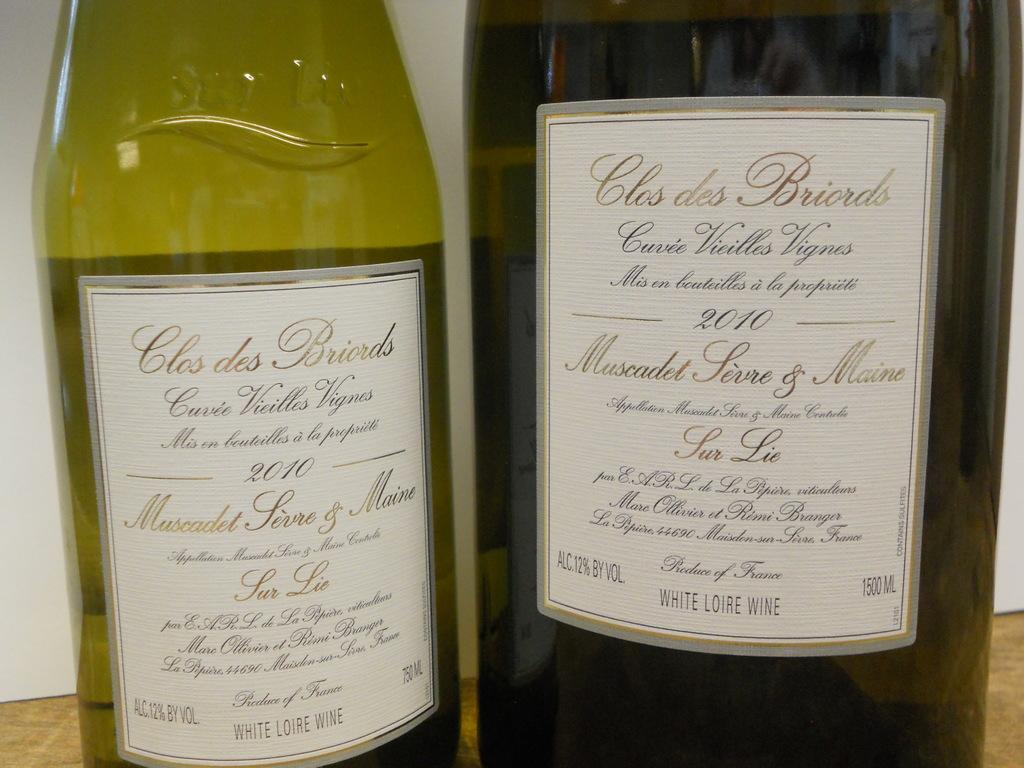What objects are present on the table in the image? There are two wine bottles on the table in the image. Can you describe the table setting or any other objects on the table? The provided facts do not mention any other objects on the table, so we cannot describe a table setting or any other objects. How many goldfish are swimming in the wine bottles in the image? There are no goldfish present in the image; it features two wine bottles on a table. 